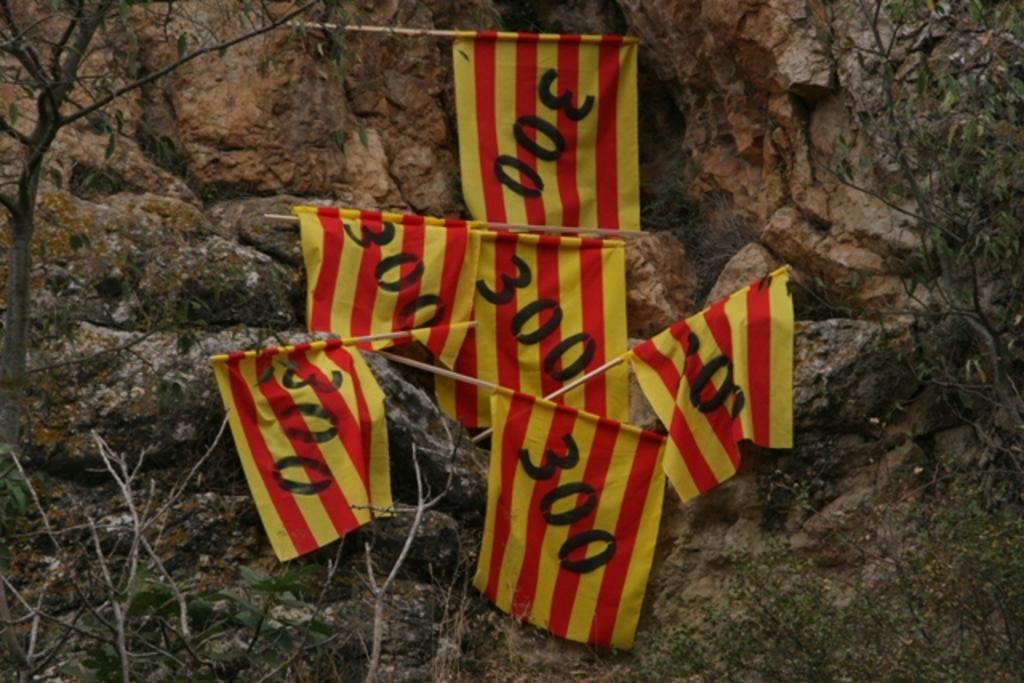Can you describe this image briefly? In this image, we can see flags on the rock. There are branches on the left and on the right side of the image. 